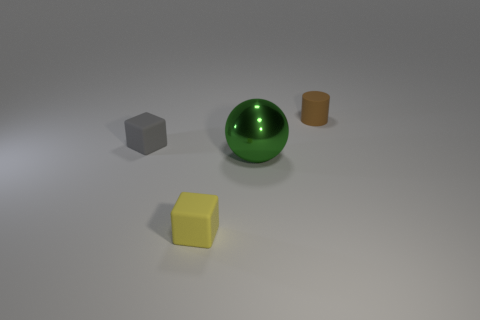What can you infer about the lighting conditions in the scene? The lighting in the scene seems to be diffused, coming from above. This is indicated by the soft shadows cast beneath each object, which lack the sharpness that direct lighting would create. The lack of any harsh shadows or bright highlights on the objects also supports the idea of a diffused overhead light source. 